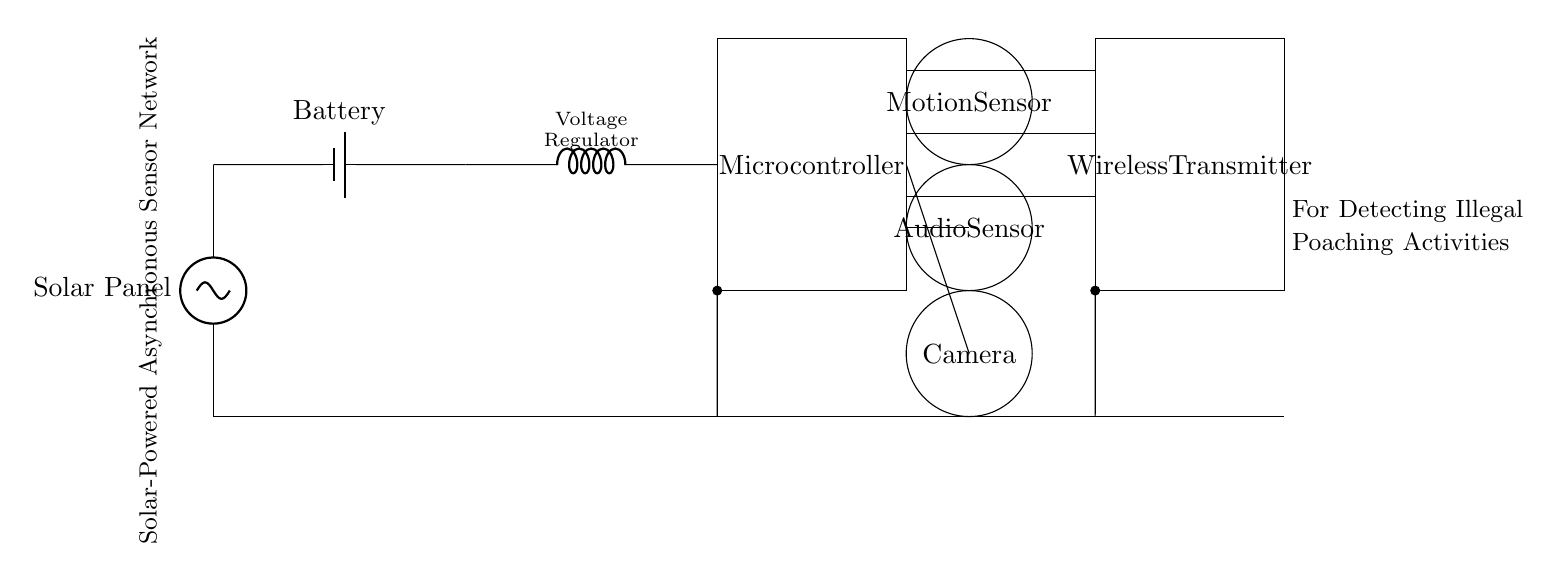What are the main components in this circuit? The main components in the circuit include a solar panel, battery, voltage regulator, microcontroller, multiple sensors (motion, audio, camera), and a wireless transmitter.
Answer: Solar panel, battery, voltage regulator, microcontroller, motion sensor, audio sensor, camera, wireless transmitter What kind of power source does this circuit utilize? The circuit utilizes solar power as indicated by the solar panel at the front of the diagram. The solar panel converts sunlight into electrical energy.
Answer: Solar power How many sensors are present in the circuit? There are three sensors in the circuit: a motion sensor, an audio sensor, and a camera. They each serve to detect different types of poaching activities.
Answer: Three What type of network is this circuit designed for? The circuit is designed for an asynchronous sensor network, which implies that sensors operate independently and communicate findings as they detect events.
Answer: Asynchronous sensor network How does the voltage regulator contribute to the circuit? The voltage regulator ensures that the microcontroller and sensors receive a stable voltage regardless of variations from the battery or solar panel, providing consistent performance.
Answer: Stabilizes voltage What is the function of the wireless transmitter in this circuit? The wireless transmitter is responsible for sending the data collected by the sensors to a remote monitor or database for evaluation and response without needing wired connections.
Answer: Sends data wirelessly What type of monitoring does the audio sensor perform? The audio sensor monitors sounds in the environment, which can help detect illegal poaching activities through sounds of gunshots or animal distress.
Answer: Sound monitoring 